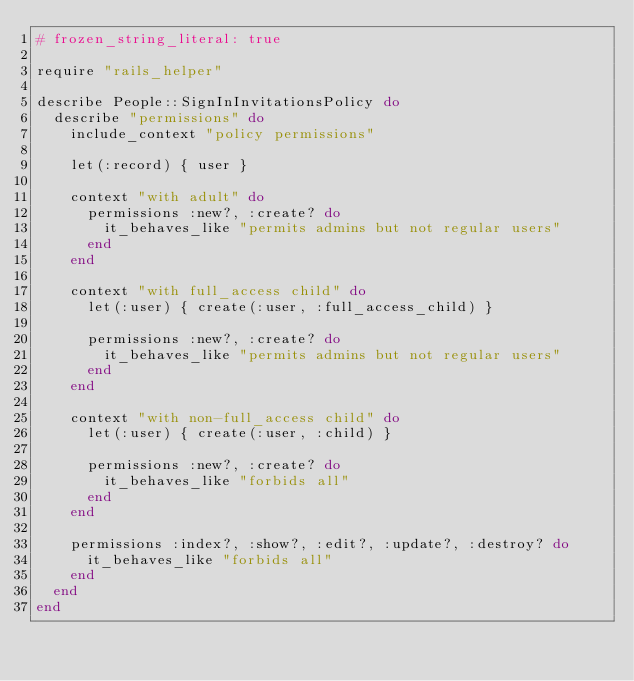Convert code to text. <code><loc_0><loc_0><loc_500><loc_500><_Ruby_># frozen_string_literal: true

require "rails_helper"

describe People::SignInInvitationsPolicy do
  describe "permissions" do
    include_context "policy permissions"

    let(:record) { user }

    context "with adult" do
      permissions :new?, :create? do
        it_behaves_like "permits admins but not regular users"
      end
    end

    context "with full_access child" do
      let(:user) { create(:user, :full_access_child) }

      permissions :new?, :create? do
        it_behaves_like "permits admins but not regular users"
      end
    end

    context "with non-full_access child" do
      let(:user) { create(:user, :child) }

      permissions :new?, :create? do
        it_behaves_like "forbids all"
      end
    end

    permissions :index?, :show?, :edit?, :update?, :destroy? do
      it_behaves_like "forbids all"
    end
  end
end
</code> 